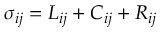Convert formula to latex. <formula><loc_0><loc_0><loc_500><loc_500>\sigma _ { i j } = L _ { i j } + C _ { i j } + R _ { i j }</formula> 